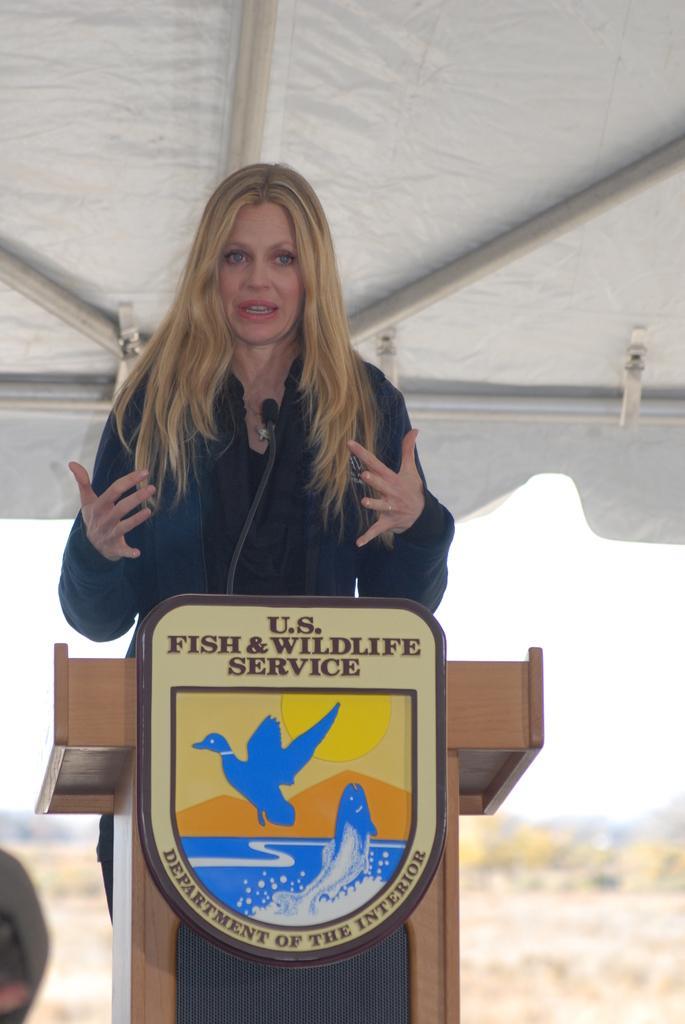Describe this image in one or two sentences. In this picture I can observe a woman standing in front of a podium in the middle of the picture. The background is blurred. 